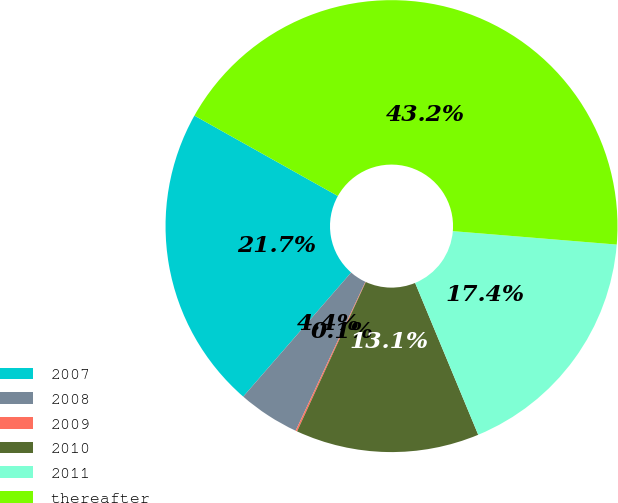Convert chart. <chart><loc_0><loc_0><loc_500><loc_500><pie_chart><fcel>2007<fcel>2008<fcel>2009<fcel>2010<fcel>2011<fcel>thereafter<nl><fcel>21.74%<fcel>4.42%<fcel>0.11%<fcel>13.13%<fcel>17.43%<fcel>43.17%<nl></chart> 